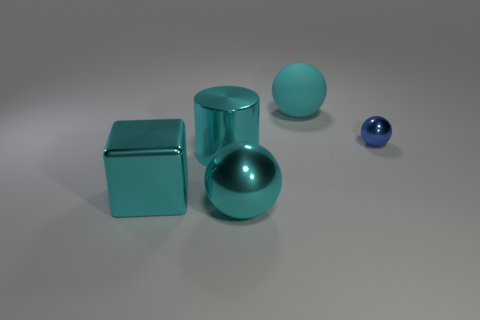Subtract all blue spheres. How many spheres are left? 2 Add 1 big cyan metallic things. How many objects exist? 6 Subtract all blue spheres. How many spheres are left? 2 Subtract all gray cylinders. How many cyan balls are left? 2 Subtract 3 spheres. How many spheres are left? 0 Subtract 0 red spheres. How many objects are left? 5 Subtract all balls. How many objects are left? 2 Subtract all green spheres. Subtract all yellow blocks. How many spheres are left? 3 Subtract all large spheres. Subtract all small things. How many objects are left? 2 Add 2 cyan matte spheres. How many cyan matte spheres are left? 3 